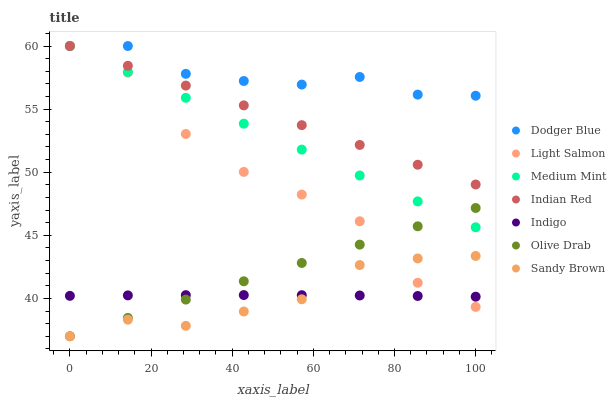Does Sandy Brown have the minimum area under the curve?
Answer yes or no. Yes. Does Dodger Blue have the maximum area under the curve?
Answer yes or no. Yes. Does Light Salmon have the minimum area under the curve?
Answer yes or no. No. Does Light Salmon have the maximum area under the curve?
Answer yes or no. No. Is Olive Drab the smoothest?
Answer yes or no. Yes. Is Light Salmon the roughest?
Answer yes or no. Yes. Is Indigo the smoothest?
Answer yes or no. No. Is Indigo the roughest?
Answer yes or no. No. Does Sandy Brown have the lowest value?
Answer yes or no. Yes. Does Light Salmon have the lowest value?
Answer yes or no. No. Does Indian Red have the highest value?
Answer yes or no. Yes. Does Indigo have the highest value?
Answer yes or no. No. Is Olive Drab less than Dodger Blue?
Answer yes or no. Yes. Is Dodger Blue greater than Indigo?
Answer yes or no. Yes. Does Indigo intersect Olive Drab?
Answer yes or no. Yes. Is Indigo less than Olive Drab?
Answer yes or no. No. Is Indigo greater than Olive Drab?
Answer yes or no. No. Does Olive Drab intersect Dodger Blue?
Answer yes or no. No. 